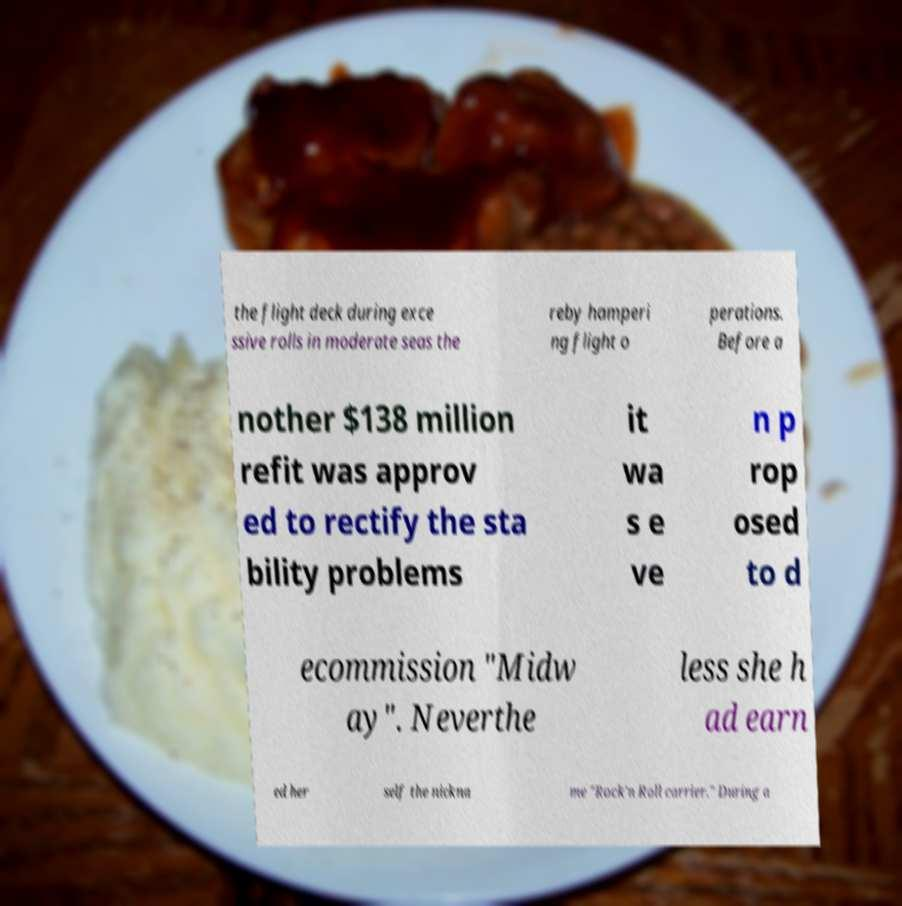Can you read and provide the text displayed in the image?This photo seems to have some interesting text. Can you extract and type it out for me? the flight deck during exce ssive rolls in moderate seas the reby hamperi ng flight o perations. Before a nother $138 million refit was approv ed to rectify the sta bility problems it wa s e ve n p rop osed to d ecommission "Midw ay". Neverthe less she h ad earn ed her self the nickna me "Rock'n Roll carrier." During a 